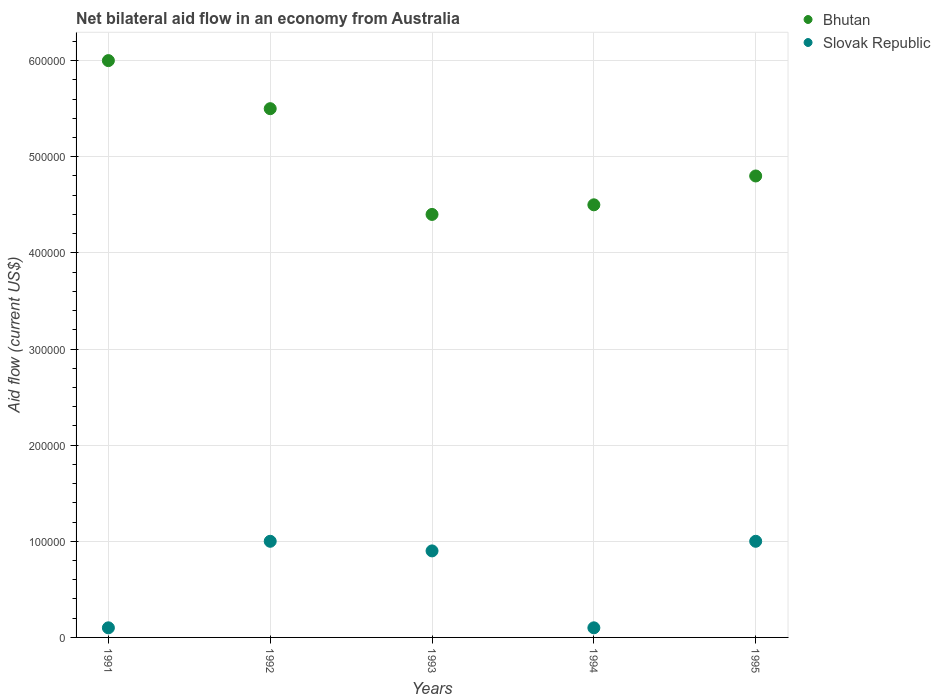Is the number of dotlines equal to the number of legend labels?
Provide a succinct answer. Yes. Across all years, what is the maximum net bilateral aid flow in Bhutan?
Your response must be concise. 6.00e+05. Across all years, what is the minimum net bilateral aid flow in Bhutan?
Offer a very short reply. 4.40e+05. What is the total net bilateral aid flow in Slovak Republic in the graph?
Provide a succinct answer. 3.10e+05. What is the difference between the net bilateral aid flow in Slovak Republic in 1991 and the net bilateral aid flow in Bhutan in 1995?
Your answer should be very brief. -4.70e+05. What is the average net bilateral aid flow in Slovak Republic per year?
Provide a short and direct response. 6.20e+04. In the year 1991, what is the difference between the net bilateral aid flow in Bhutan and net bilateral aid flow in Slovak Republic?
Keep it short and to the point. 5.90e+05. In how many years, is the net bilateral aid flow in Bhutan greater than 420000 US$?
Give a very brief answer. 5. What is the ratio of the net bilateral aid flow in Bhutan in 1991 to that in 1993?
Offer a terse response. 1.36. Is the net bilateral aid flow in Bhutan in 1993 less than that in 1995?
Provide a succinct answer. Yes. What is the difference between the highest and the second highest net bilateral aid flow in Bhutan?
Offer a very short reply. 5.00e+04. What is the difference between the highest and the lowest net bilateral aid flow in Bhutan?
Provide a short and direct response. 1.60e+05. In how many years, is the net bilateral aid flow in Slovak Republic greater than the average net bilateral aid flow in Slovak Republic taken over all years?
Keep it short and to the point. 3. Is the sum of the net bilateral aid flow in Bhutan in 1991 and 1994 greater than the maximum net bilateral aid flow in Slovak Republic across all years?
Make the answer very short. Yes. Is the net bilateral aid flow in Slovak Republic strictly greater than the net bilateral aid flow in Bhutan over the years?
Offer a terse response. No. Is the net bilateral aid flow in Slovak Republic strictly less than the net bilateral aid flow in Bhutan over the years?
Provide a succinct answer. Yes. How many years are there in the graph?
Your response must be concise. 5. What is the difference between two consecutive major ticks on the Y-axis?
Provide a short and direct response. 1.00e+05. Are the values on the major ticks of Y-axis written in scientific E-notation?
Keep it short and to the point. No. Does the graph contain any zero values?
Keep it short and to the point. No. How many legend labels are there?
Offer a very short reply. 2. How are the legend labels stacked?
Make the answer very short. Vertical. What is the title of the graph?
Your answer should be very brief. Net bilateral aid flow in an economy from Australia. What is the label or title of the Y-axis?
Give a very brief answer. Aid flow (current US$). What is the Aid flow (current US$) in Slovak Republic in 1991?
Offer a terse response. 10000. What is the Aid flow (current US$) of Slovak Republic in 1992?
Make the answer very short. 1.00e+05. What is the Aid flow (current US$) in Bhutan in 1993?
Make the answer very short. 4.40e+05. What is the Aid flow (current US$) of Bhutan in 1994?
Your answer should be compact. 4.50e+05. What is the Aid flow (current US$) in Bhutan in 1995?
Give a very brief answer. 4.80e+05. What is the Aid flow (current US$) in Slovak Republic in 1995?
Your response must be concise. 1.00e+05. Across all years, what is the maximum Aid flow (current US$) of Slovak Republic?
Your answer should be very brief. 1.00e+05. What is the total Aid flow (current US$) in Bhutan in the graph?
Ensure brevity in your answer.  2.52e+06. What is the total Aid flow (current US$) in Slovak Republic in the graph?
Provide a succinct answer. 3.10e+05. What is the difference between the Aid flow (current US$) in Bhutan in 1991 and that in 1992?
Your answer should be very brief. 5.00e+04. What is the difference between the Aid flow (current US$) in Bhutan in 1991 and that in 1993?
Keep it short and to the point. 1.60e+05. What is the difference between the Aid flow (current US$) of Slovak Republic in 1991 and that in 1993?
Your response must be concise. -8.00e+04. What is the difference between the Aid flow (current US$) of Slovak Republic in 1991 and that in 1995?
Ensure brevity in your answer.  -9.00e+04. What is the difference between the Aid flow (current US$) in Slovak Republic in 1992 and that in 1995?
Provide a short and direct response. 0. What is the difference between the Aid flow (current US$) in Bhutan in 1993 and that in 1994?
Your answer should be compact. -10000. What is the difference between the Aid flow (current US$) in Slovak Republic in 1993 and that in 1994?
Provide a succinct answer. 8.00e+04. What is the difference between the Aid flow (current US$) in Bhutan in 1993 and that in 1995?
Provide a short and direct response. -4.00e+04. What is the difference between the Aid flow (current US$) of Bhutan in 1991 and the Aid flow (current US$) of Slovak Republic in 1992?
Make the answer very short. 5.00e+05. What is the difference between the Aid flow (current US$) in Bhutan in 1991 and the Aid flow (current US$) in Slovak Republic in 1993?
Give a very brief answer. 5.10e+05. What is the difference between the Aid flow (current US$) in Bhutan in 1991 and the Aid flow (current US$) in Slovak Republic in 1994?
Make the answer very short. 5.90e+05. What is the difference between the Aid flow (current US$) of Bhutan in 1991 and the Aid flow (current US$) of Slovak Republic in 1995?
Give a very brief answer. 5.00e+05. What is the difference between the Aid flow (current US$) of Bhutan in 1992 and the Aid flow (current US$) of Slovak Republic in 1994?
Give a very brief answer. 5.40e+05. What is the difference between the Aid flow (current US$) in Bhutan in 1992 and the Aid flow (current US$) in Slovak Republic in 1995?
Give a very brief answer. 4.50e+05. What is the difference between the Aid flow (current US$) in Bhutan in 1994 and the Aid flow (current US$) in Slovak Republic in 1995?
Make the answer very short. 3.50e+05. What is the average Aid flow (current US$) of Bhutan per year?
Keep it short and to the point. 5.04e+05. What is the average Aid flow (current US$) in Slovak Republic per year?
Keep it short and to the point. 6.20e+04. In the year 1991, what is the difference between the Aid flow (current US$) of Bhutan and Aid flow (current US$) of Slovak Republic?
Ensure brevity in your answer.  5.90e+05. In the year 1992, what is the difference between the Aid flow (current US$) in Bhutan and Aid flow (current US$) in Slovak Republic?
Offer a terse response. 4.50e+05. In the year 1994, what is the difference between the Aid flow (current US$) in Bhutan and Aid flow (current US$) in Slovak Republic?
Give a very brief answer. 4.40e+05. In the year 1995, what is the difference between the Aid flow (current US$) in Bhutan and Aid flow (current US$) in Slovak Republic?
Provide a short and direct response. 3.80e+05. What is the ratio of the Aid flow (current US$) of Bhutan in 1991 to that in 1992?
Offer a terse response. 1.09. What is the ratio of the Aid flow (current US$) in Slovak Republic in 1991 to that in 1992?
Offer a terse response. 0.1. What is the ratio of the Aid flow (current US$) in Bhutan in 1991 to that in 1993?
Your response must be concise. 1.36. What is the ratio of the Aid flow (current US$) of Bhutan in 1991 to that in 1994?
Provide a succinct answer. 1.33. What is the ratio of the Aid flow (current US$) of Bhutan in 1991 to that in 1995?
Provide a short and direct response. 1.25. What is the ratio of the Aid flow (current US$) of Slovak Republic in 1991 to that in 1995?
Offer a terse response. 0.1. What is the ratio of the Aid flow (current US$) of Bhutan in 1992 to that in 1993?
Offer a terse response. 1.25. What is the ratio of the Aid flow (current US$) in Bhutan in 1992 to that in 1994?
Ensure brevity in your answer.  1.22. What is the ratio of the Aid flow (current US$) in Bhutan in 1992 to that in 1995?
Offer a terse response. 1.15. What is the ratio of the Aid flow (current US$) in Slovak Republic in 1992 to that in 1995?
Keep it short and to the point. 1. What is the ratio of the Aid flow (current US$) of Bhutan in 1993 to that in 1994?
Keep it short and to the point. 0.98. What is the ratio of the Aid flow (current US$) of Slovak Republic in 1993 to that in 1994?
Your answer should be compact. 9. What is the ratio of the Aid flow (current US$) of Slovak Republic in 1993 to that in 1995?
Give a very brief answer. 0.9. What is the ratio of the Aid flow (current US$) of Bhutan in 1994 to that in 1995?
Provide a succinct answer. 0.94. What is the ratio of the Aid flow (current US$) in Slovak Republic in 1994 to that in 1995?
Your answer should be very brief. 0.1. What is the difference between the highest and the second highest Aid flow (current US$) in Bhutan?
Keep it short and to the point. 5.00e+04. What is the difference between the highest and the second highest Aid flow (current US$) of Slovak Republic?
Give a very brief answer. 0. What is the difference between the highest and the lowest Aid flow (current US$) in Slovak Republic?
Your answer should be very brief. 9.00e+04. 